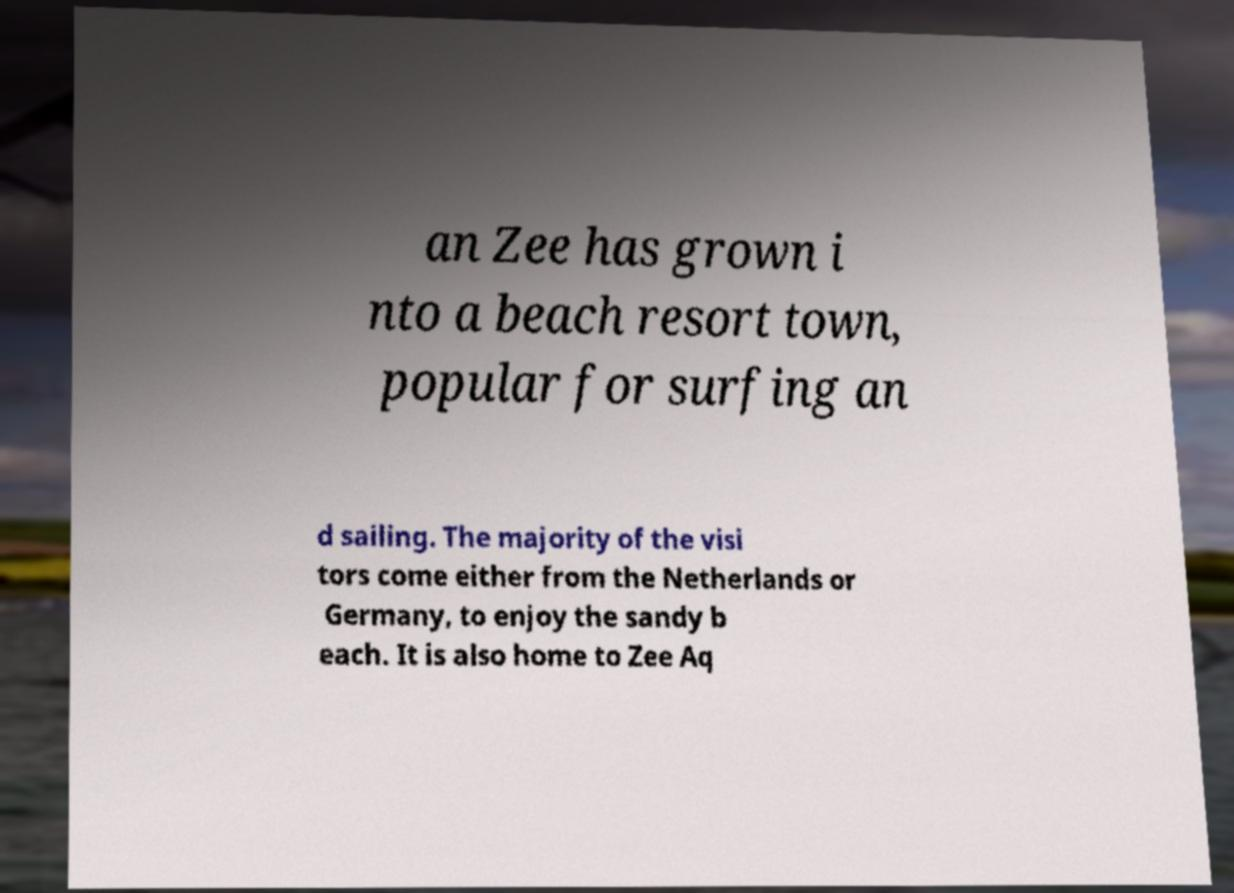Can you read and provide the text displayed in the image?This photo seems to have some interesting text. Can you extract and type it out for me? an Zee has grown i nto a beach resort town, popular for surfing an d sailing. The majority of the visi tors come either from the Netherlands or Germany, to enjoy the sandy b each. It is also home to Zee Aq 